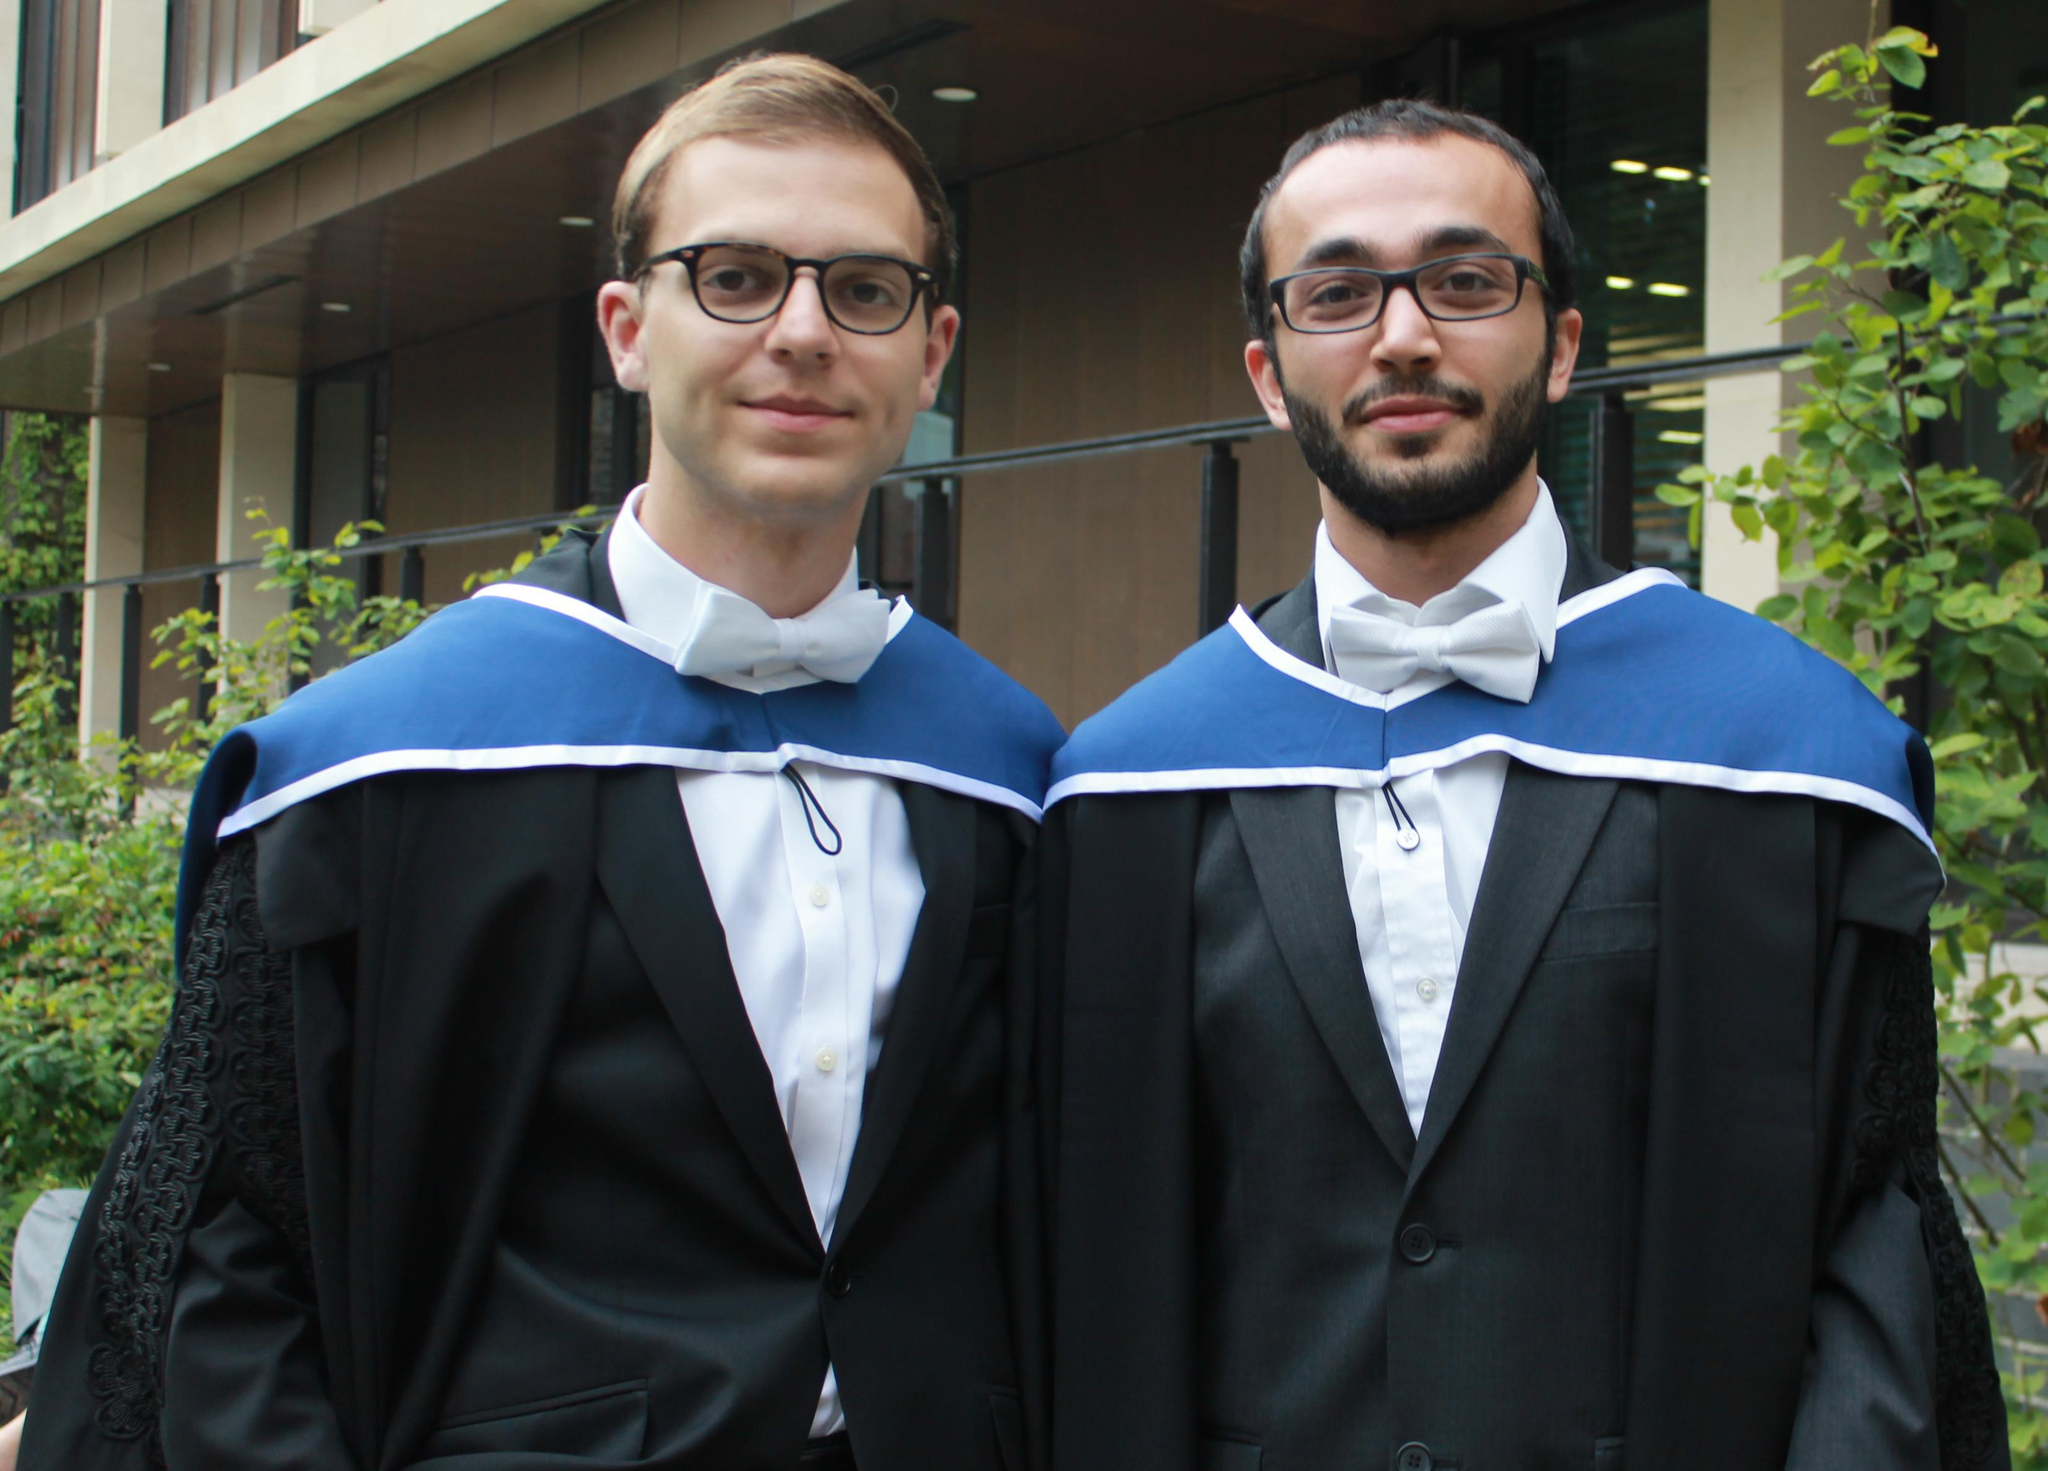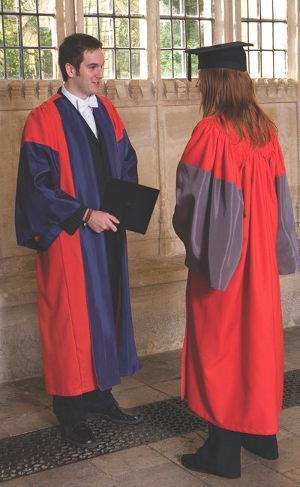The first image is the image on the left, the second image is the image on the right. Analyze the images presented: Is the assertion "There are no more than 3 graduates pictured." valid? Answer yes or no. No. The first image is the image on the left, the second image is the image on the right. For the images shown, is this caption "Right image shows one male graduate posed in colorful gown on grass." true? Answer yes or no. No. 